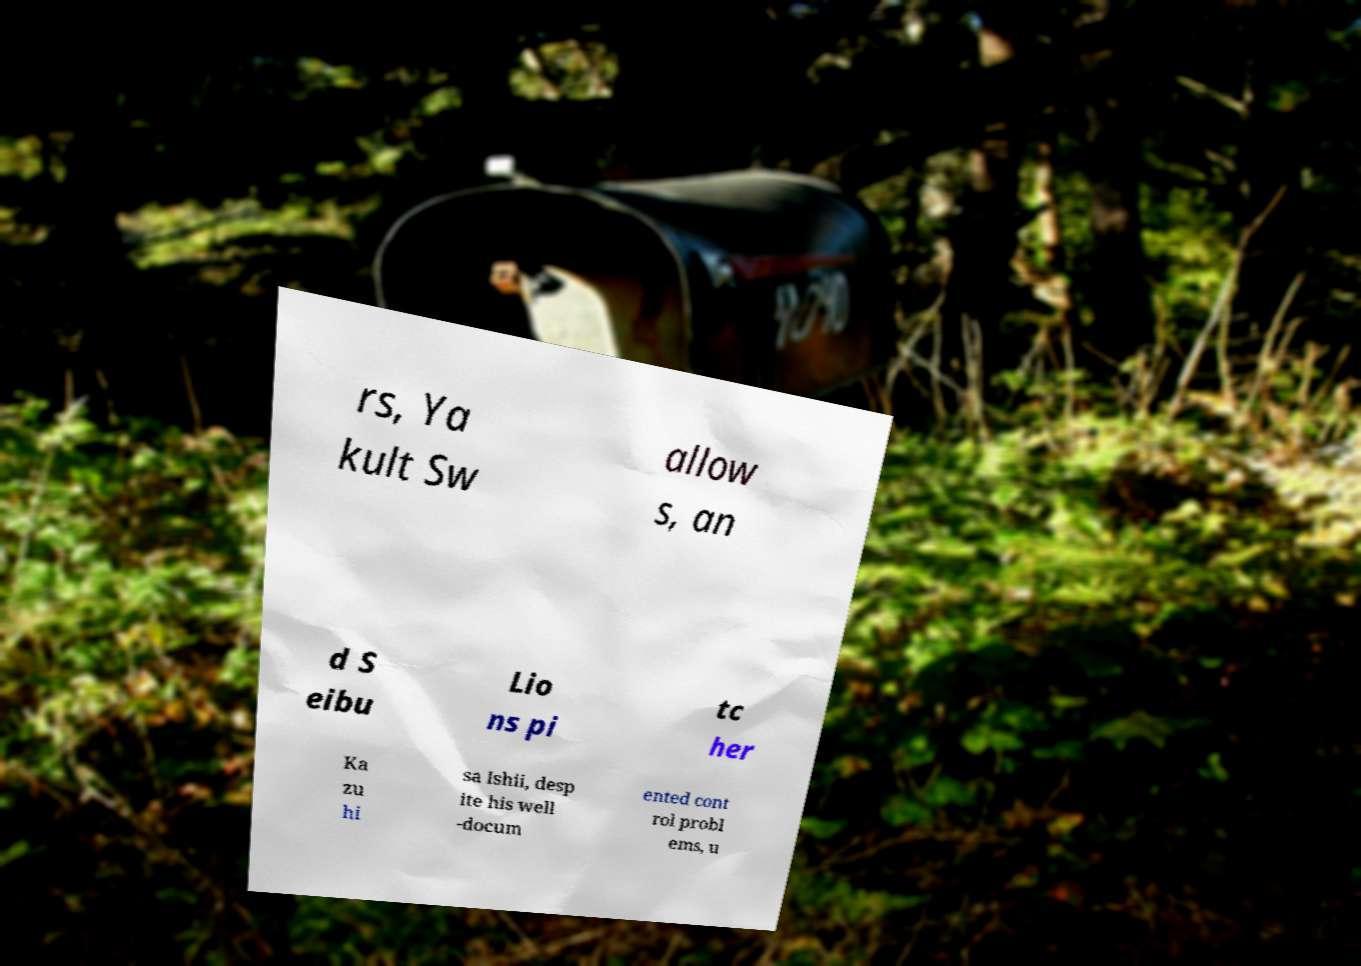Can you accurately transcribe the text from the provided image for me? rs, Ya kult Sw allow s, an d S eibu Lio ns pi tc her Ka zu hi sa Ishii, desp ite his well -docum ented cont rol probl ems, u 